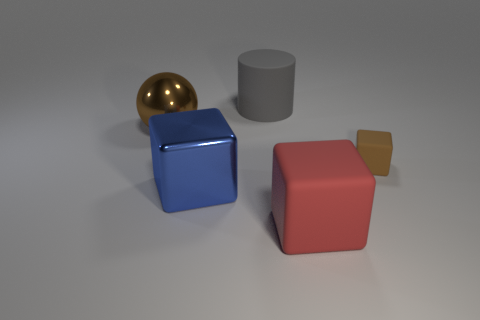Subtract all rubber cubes. How many cubes are left? 1 Add 1 tiny brown things. How many objects exist? 6 Subtract all blocks. How many objects are left? 2 Subtract 1 cubes. How many cubes are left? 2 Add 3 big yellow things. How many big yellow things exist? 3 Subtract 0 purple spheres. How many objects are left? 5 Subtract all brown cubes. Subtract all yellow spheres. How many cubes are left? 2 Subtract all small brown things. Subtract all blue cubes. How many objects are left? 3 Add 4 big gray rubber objects. How many big gray rubber objects are left? 5 